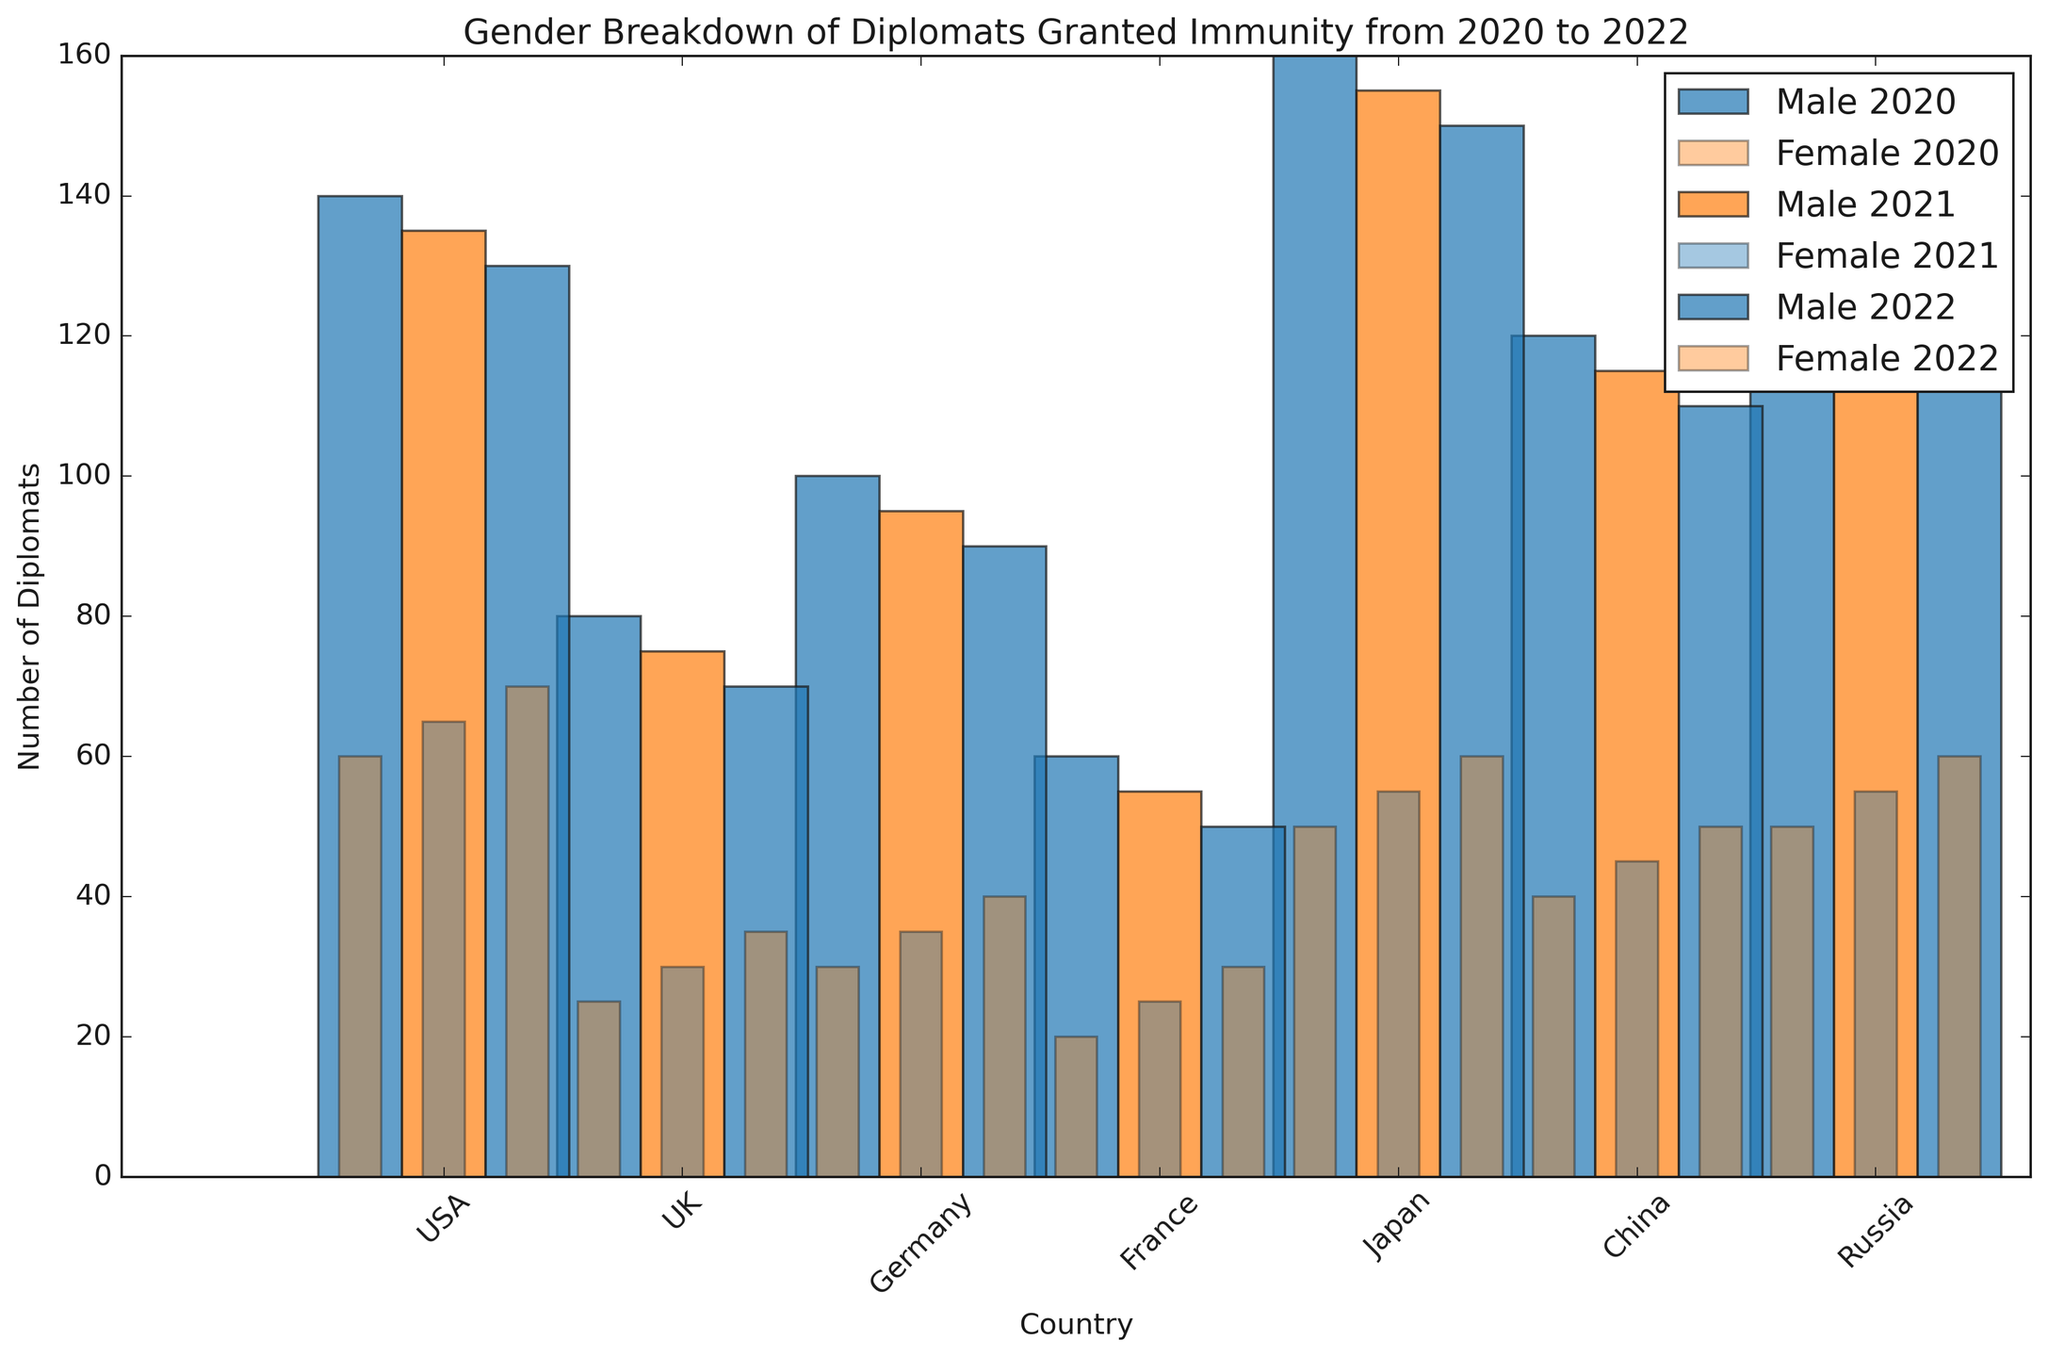What is the total number of male diplomats from the USA in 2020, 2021, and 2022 combined? To find the total number of male diplomats from the USA over the three years, sum the values for each year: 150 (2020) + 145 (2021) + 140 (2022).
Answer: 435 Which country had the highest number of female diplomats in 2022? To determine which country had the highest number of female diplomats in 2022, compare the female diplomat numbers for each country in that year: USA (60), UK (50), Germany (40), France (35), Japan (30), China (70), Russia (60).
Answer: China In which year did Germany have more female diplomats than male diplomats? To determine if there was any year in which Germany had more female diplomats than male diplomats, compare the counts for each year. For 2020: 30 (female) vs 100 (male), for 2021: 35 (female) vs 95 (male), and for 2022: 40 (female) vs 90 (male). Germany never had more female than male diplomats.
Answer: Never How does the number of male diplomats in Russia in 2021 compare to the number of male diplomats in China in the same year? To make this comparison, check the number of male diplomats for Russia (155) and China (135) in 2021. Notice which number is greater.
Answer: Russia had more What is the difference between the number of male diplomats in France in 2020 and 2022? To find the difference, subtract the number of male diplomats in 2022 from the number in 2020 for France: 80 (2020) - 70 (2022).
Answer: 10 How many countries had exactly 50 female diplomats in 2022? To find out how many countries had exactly 50 female diplomats in 2022, scan each country’s data for 2022 and tally those with 50 female diplomats: USA (60), UK (50), Germany (40), France (35), Japan (30), China (70), Russia (60). Only the UK had exactly 50 female diplomats.
Answer: 1 In which year did Japan have the smallest number of male diplomats? Compare the number of male diplomats in Japan for each year: 2020 (60), 2021 (55), 2022 (50). The smallest number was in 2022.
Answer: 2022 Across all years, which country shows the greatest increase in the number of female diplomats from 2020 to 2022? Calculate the increase in the number of female diplomats for each country from 2020 to 2022: USA increased by 10, UK by 10, Germany by 10, France by 10, Japan by 10, China by 10, Russia by 10. Each country shows the same increase.
Answer: All countries show the same increase What is the average number of female diplomats in the UK over the three years? Add the number of female diplomats in the UK for each year and divide by the number of years: (40 + 45 + 50) / 3 = 135 / 3.
Answer: 45 